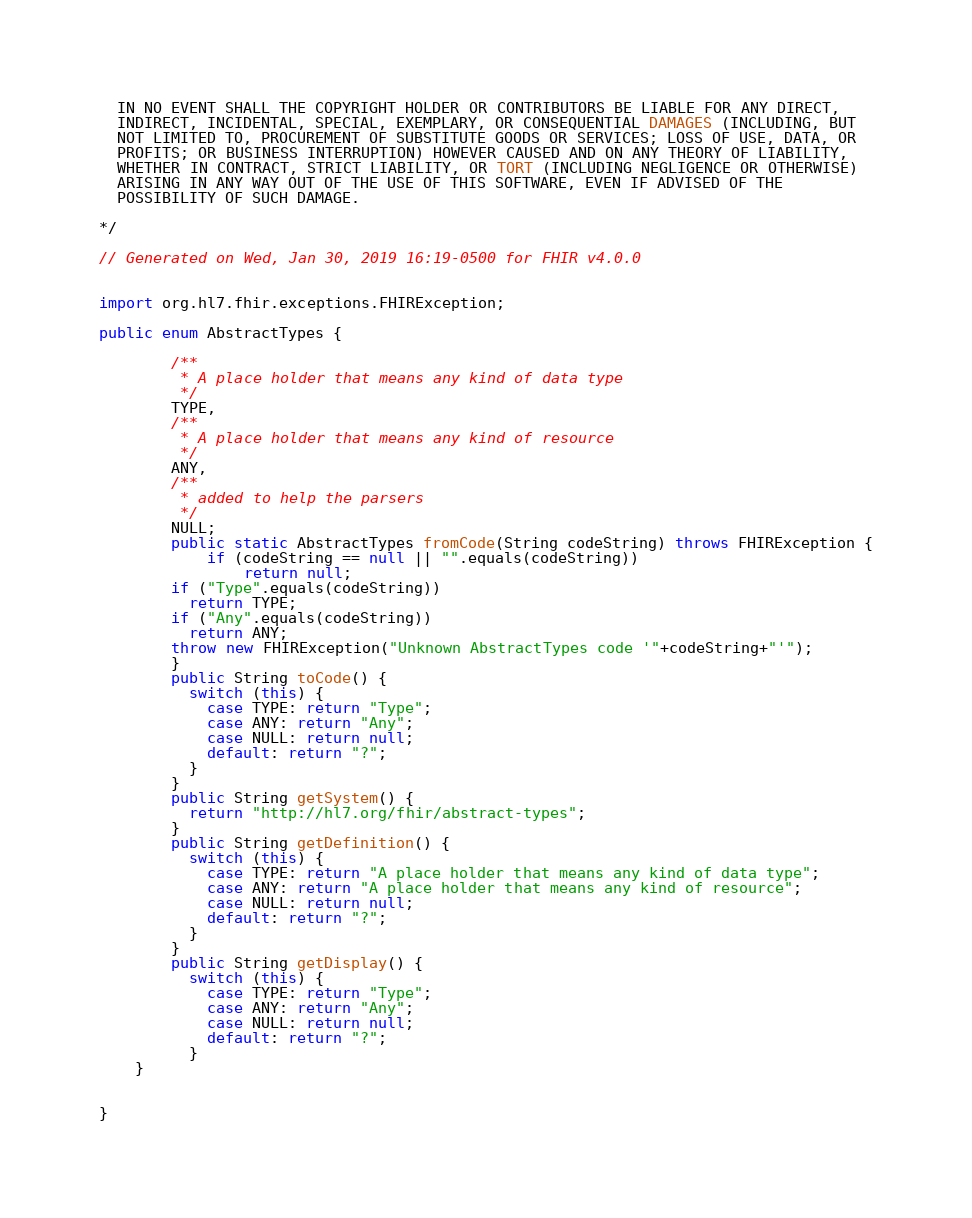Convert code to text. <code><loc_0><loc_0><loc_500><loc_500><_Java_>  IN NO EVENT SHALL THE COPYRIGHT HOLDER OR CONTRIBUTORS BE LIABLE FOR ANY DIRECT, 
  INDIRECT, INCIDENTAL, SPECIAL, EXEMPLARY, OR CONSEQUENTIAL DAMAGES (INCLUDING, BUT 
  NOT LIMITED TO, PROCUREMENT OF SUBSTITUTE GOODS OR SERVICES; LOSS OF USE, DATA, OR 
  PROFITS; OR BUSINESS INTERRUPTION) HOWEVER CAUSED AND ON ANY THEORY OF LIABILITY, 
  WHETHER IN CONTRACT, STRICT LIABILITY, OR TORT (INCLUDING NEGLIGENCE OR OTHERWISE) 
  ARISING IN ANY WAY OUT OF THE USE OF THIS SOFTWARE, EVEN IF ADVISED OF THE 
  POSSIBILITY OF SUCH DAMAGE.
  
*/

// Generated on Wed, Jan 30, 2019 16:19-0500 for FHIR v4.0.0


import org.hl7.fhir.exceptions.FHIRException;

public enum AbstractTypes {

        /**
         * A place holder that means any kind of data type
         */
        TYPE, 
        /**
         * A place holder that means any kind of resource
         */
        ANY, 
        /**
         * added to help the parsers
         */
        NULL;
        public static AbstractTypes fromCode(String codeString) throws FHIRException {
            if (codeString == null || "".equals(codeString))
                return null;
        if ("Type".equals(codeString))
          return TYPE;
        if ("Any".equals(codeString))
          return ANY;
        throw new FHIRException("Unknown AbstractTypes code '"+codeString+"'");
        }
        public String toCode() {
          switch (this) {
            case TYPE: return "Type";
            case ANY: return "Any";
            case NULL: return null;
            default: return "?";
          }
        }
        public String getSystem() {
          return "http://hl7.org/fhir/abstract-types";
        }
        public String getDefinition() {
          switch (this) {
            case TYPE: return "A place holder that means any kind of data type";
            case ANY: return "A place holder that means any kind of resource";
            case NULL: return null;
            default: return "?";
          }
        }
        public String getDisplay() {
          switch (this) {
            case TYPE: return "Type";
            case ANY: return "Any";
            case NULL: return null;
            default: return "?";
          }
    }


}</code> 